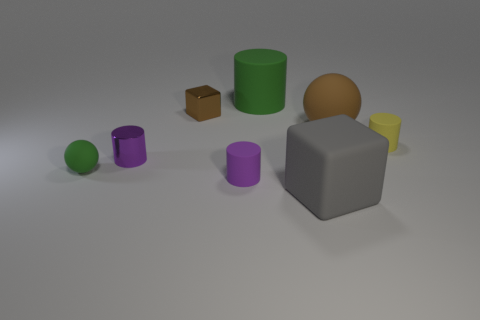There is a small thing that is the same color as the large cylinder; what material is it?
Give a very brief answer. Rubber. There is a ball that is to the right of the gray thing; is its color the same as the metallic cube?
Your answer should be very brief. Yes. Are there any rubber objects of the same color as the metallic cube?
Keep it short and to the point. Yes. There is a sphere right of the gray object; is its size the same as the tiny yellow rubber cylinder?
Give a very brief answer. No. Are there fewer big red rubber blocks than gray blocks?
Offer a very short reply. Yes. What is the shape of the matte thing behind the brown object that is to the right of the rubber object behind the brown metallic block?
Your answer should be compact. Cylinder. Are there any brown spheres made of the same material as the gray cube?
Keep it short and to the point. Yes. Is the color of the block that is left of the rubber cube the same as the matte ball right of the large gray object?
Keep it short and to the point. Yes. Are there fewer tiny shiny cylinders to the right of the tiny purple matte thing than tiny shiny things?
Provide a short and direct response. Yes. How many things are either tiny brown rubber cubes or big things in front of the small brown shiny cube?
Ensure brevity in your answer.  2. 